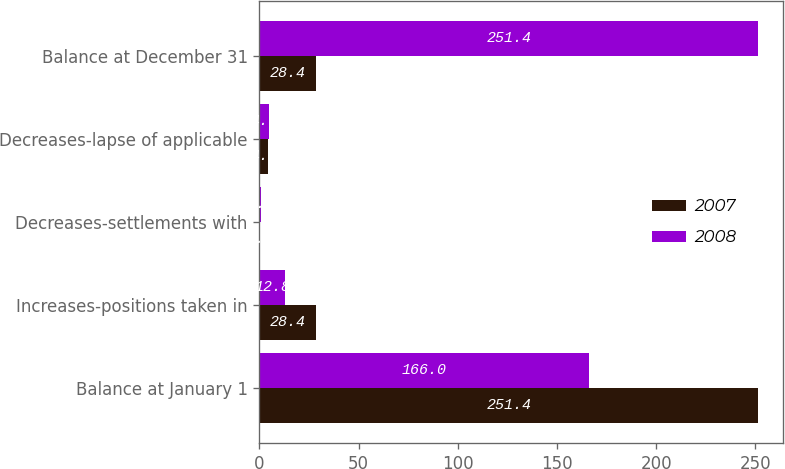Convert chart to OTSL. <chart><loc_0><loc_0><loc_500><loc_500><stacked_bar_chart><ecel><fcel>Balance at January 1<fcel>Increases-positions taken in<fcel>Decreases-settlements with<fcel>Decreases-lapse of applicable<fcel>Balance at December 31<nl><fcel>2007<fcel>251.4<fcel>28.4<fcel>0.2<fcel>4.3<fcel>28.4<nl><fcel>2008<fcel>166<fcel>12.8<fcel>0.7<fcel>4.7<fcel>251.4<nl></chart> 